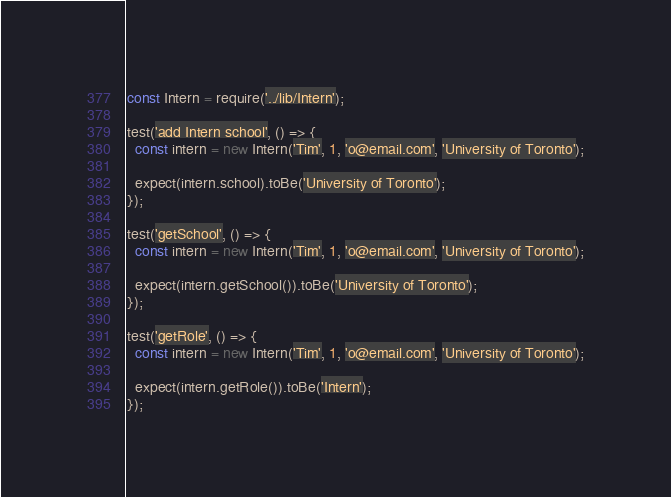<code> <loc_0><loc_0><loc_500><loc_500><_JavaScript_>const Intern = require('../lib/Intern');

test('add Intern school', () => {
  const intern = new Intern('Tim', 1, 'o@email.com', 'University of Toronto');

  expect(intern.school).toBe('University of Toronto');
});

test('getSchool', () => {
  const intern = new Intern('Tim', 1, 'o@email.com', 'University of Toronto');

  expect(intern.getSchool()).toBe('University of Toronto');
});

test('getRole', () => {
  const intern = new Intern('Tim', 1, 'o@email.com', 'University of Toronto');

  expect(intern.getRole()).toBe('Intern');
});</code> 